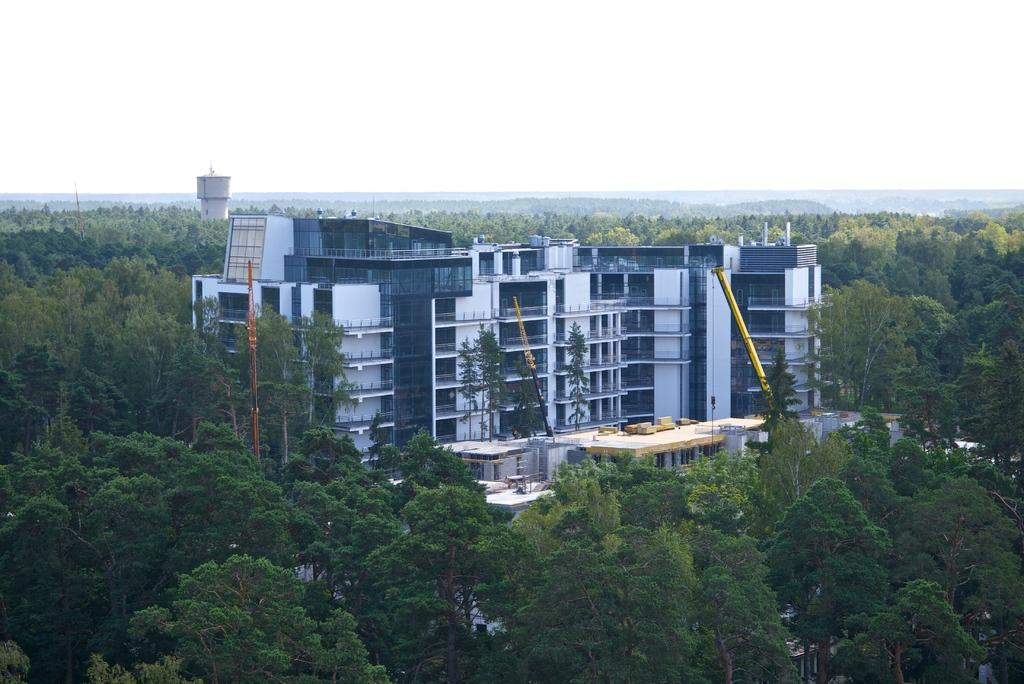What type of structure is present in the image? There is a building in the image. What other natural elements can be seen in the image? There are trees in the image. What can be seen in the distance in the image? The sky is visible in the background of the image. What grade is the building in the image? The facts provided do not mention the grade or any other information about the building's classification. --- 